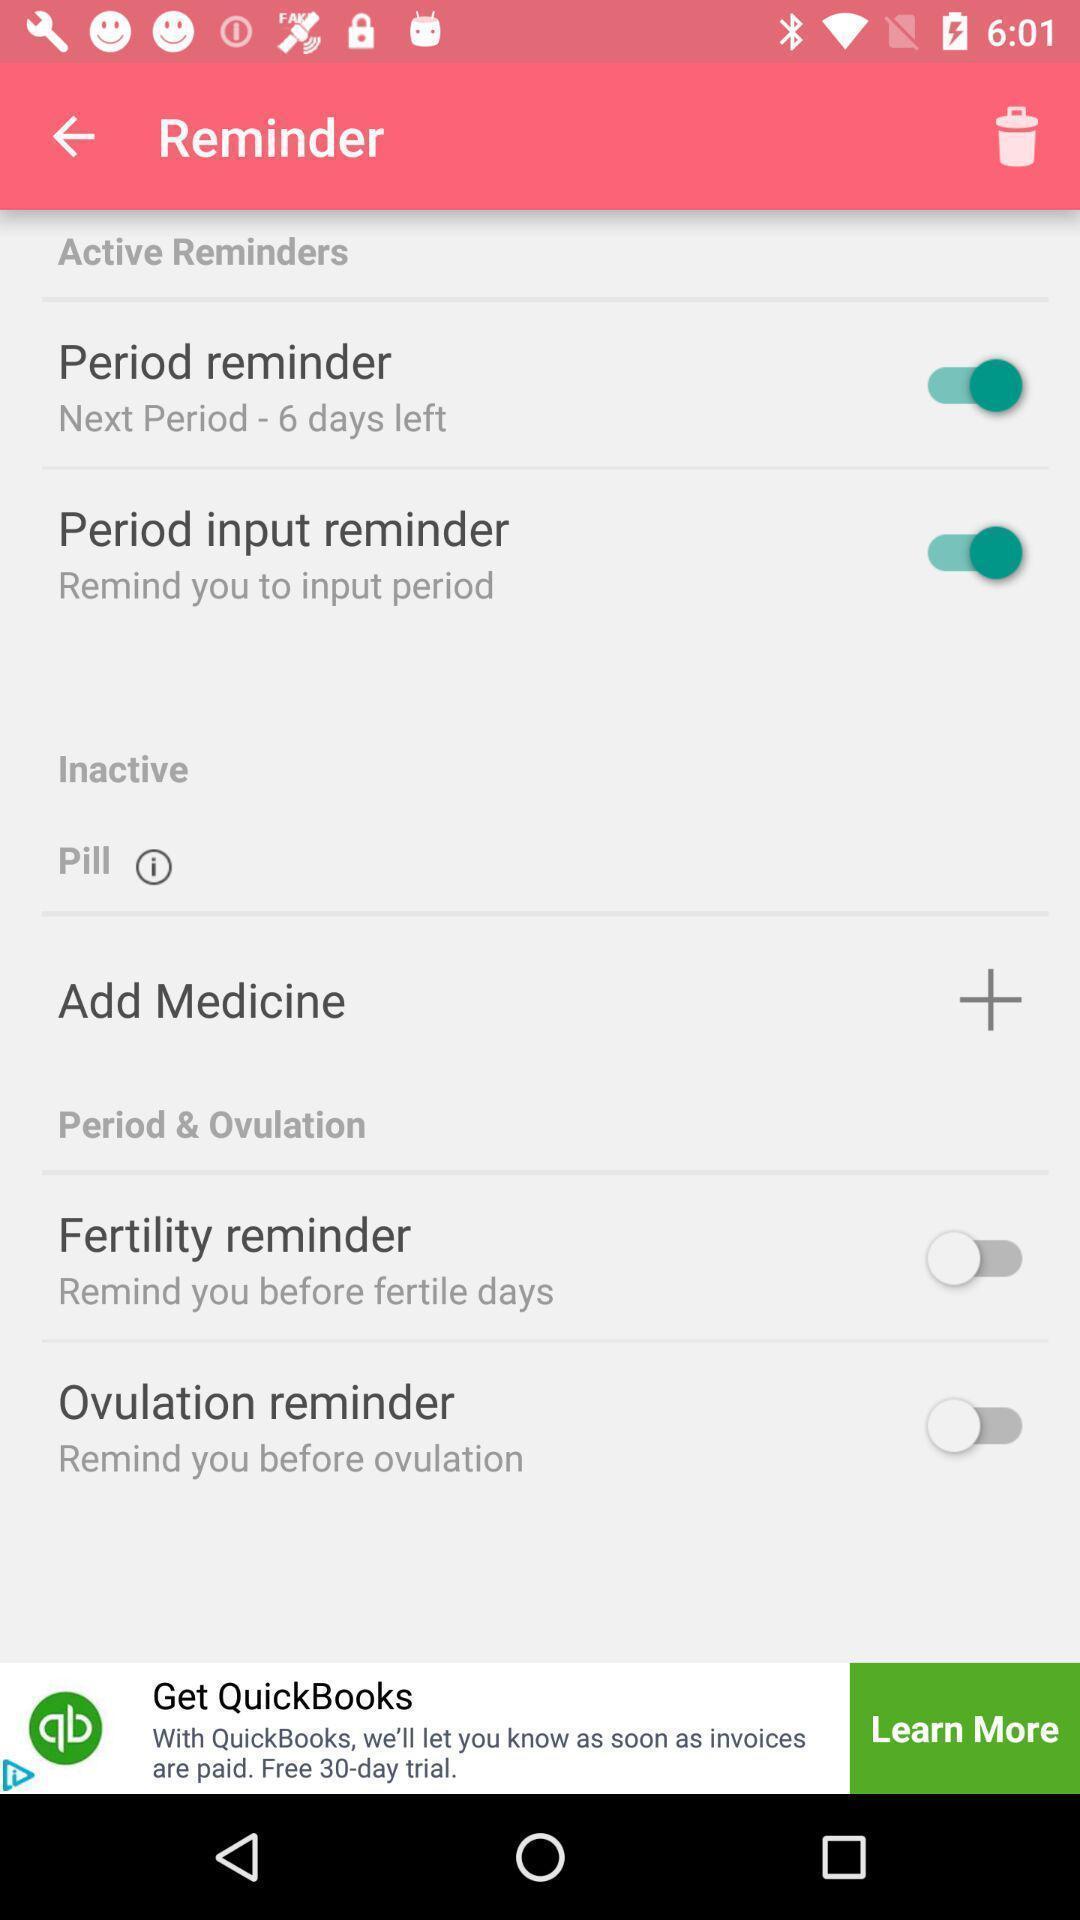Summarize the information in this screenshot. Page with multiple options for reminder of fertility status. 